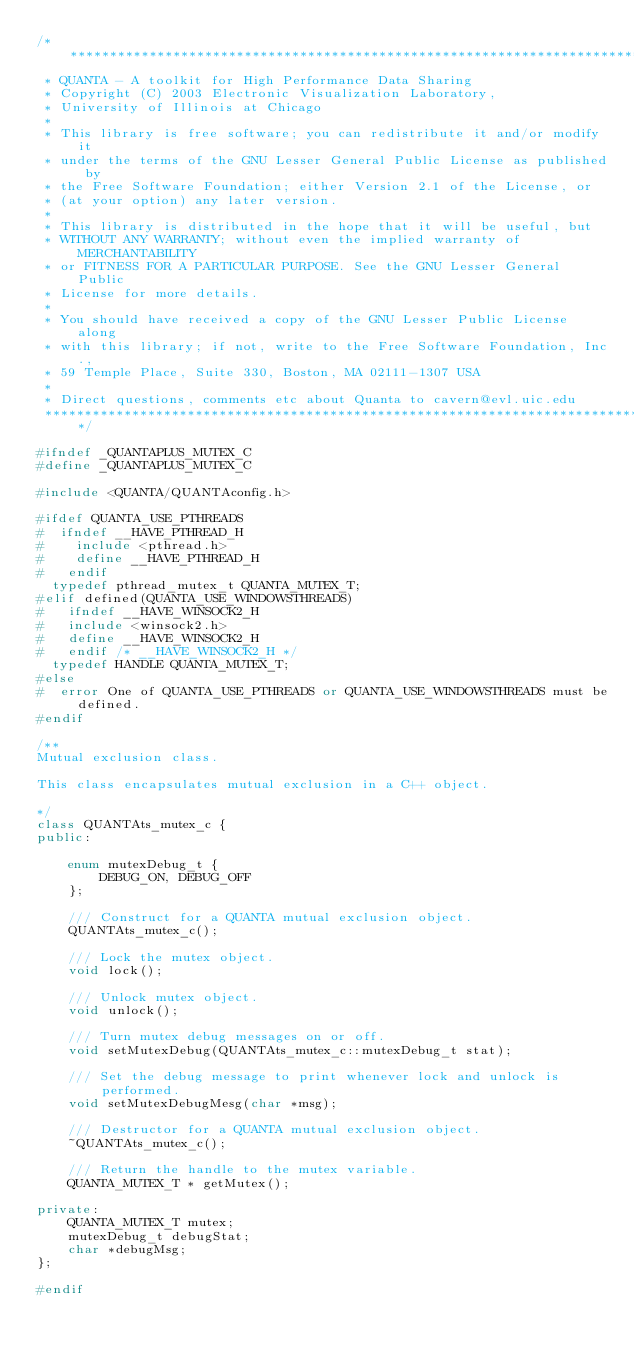Convert code to text. <code><loc_0><loc_0><loc_500><loc_500><_C++_>/******************************************************************************
 * QUANTA - A toolkit for High Performance Data Sharing
 * Copyright (C) 2003 Electronic Visualization Laboratory,  
 * University of Illinois at Chicago
 *
 * This library is free software; you can redistribute it and/or modify it 
 * under the terms of the GNU Lesser General Public License as published by
 * the Free Software Foundation; either Version 2.1 of the License, or 
 * (at your option) any later version.
 *
 * This library is distributed in the hope that it will be useful, but
 * WITHOUT ANY WARRANTY; without even the implied warranty of MERCHANTABILITY
 * or FITNESS FOR A PARTICULAR PURPOSE. See the GNU Lesser General Public 
 * License for more details.
 * 
 * You should have received a copy of the GNU Lesser Public License along
 * with this library; if not, write to the Free Software Foundation, Inc., 
 * 59 Temple Place, Suite 330, Boston, MA 02111-1307 USA
 *
 * Direct questions, comments etc about Quanta to cavern@evl.uic.edu
 *****************************************************************************/

#ifndef _QUANTAPLUS_MUTEX_C
#define _QUANTAPLUS_MUTEX_C

#include <QUANTA/QUANTAconfig.h>

#ifdef QUANTA_USE_PTHREADS
#  ifndef __HAVE_PTHREAD_H
#    include <pthread.h>
#    define __HAVE_PTHREAD_H
#   endif
  typedef pthread_mutex_t QUANTA_MUTEX_T;
#elif defined(QUANTA_USE_WINDOWSTHREADS)
#	ifndef __HAVE_WINSOCK2_H
#	include <winsock2.h>
#	define __HAVE_WINSOCK2_H
#	endif /* __HAVE_WINSOCK2_H */
  typedef HANDLE QUANTA_MUTEX_T;
#else
#  error One of QUANTA_USE_PTHREADS or QUANTA_USE_WINDOWSTHREADS must be defined.
#endif

/**
Mutual exclusion class.

This class encapsulates mutual exclusion in a C++ object.

*/
class QUANTAts_mutex_c {
public:

	enum mutexDebug_t {
		DEBUG_ON, DEBUG_OFF
	};

	/// Construct for a QUANTA mutual exclusion object.
	QUANTAts_mutex_c();

	/// Lock the mutex object.
	void lock();

	/// Unlock mutex object.
	void unlock();

	/// Turn mutex debug messages on or off.
	void setMutexDebug(QUANTAts_mutex_c::mutexDebug_t stat);

	/// Set the debug message to print whenever lock and unlock is performed.
	void setMutexDebugMesg(char *msg);

	/// Destructor for a QUANTA mutual exclusion object.
	~QUANTAts_mutex_c();

	/// Return the handle to the mutex variable.
	QUANTA_MUTEX_T * getMutex();

private:
	QUANTA_MUTEX_T mutex;
	mutexDebug_t debugStat;
	char *debugMsg;
};

#endif
</code> 